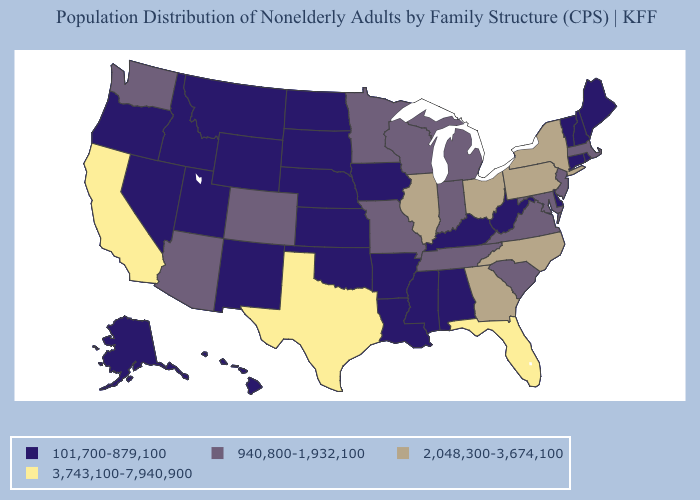What is the value of Minnesota?
Short answer required. 940,800-1,932,100. Does California have the highest value in the West?
Write a very short answer. Yes. Name the states that have a value in the range 2,048,300-3,674,100?
Be succinct. Georgia, Illinois, New York, North Carolina, Ohio, Pennsylvania. Does the map have missing data?
Short answer required. No. What is the value of Kentucky?
Quick response, please. 101,700-879,100. What is the value of Maryland?
Concise answer only. 940,800-1,932,100. Among the states that border North Carolina , does Georgia have the lowest value?
Short answer required. No. Does the map have missing data?
Concise answer only. No. What is the value of Delaware?
Quick response, please. 101,700-879,100. Name the states that have a value in the range 2,048,300-3,674,100?
Concise answer only. Georgia, Illinois, New York, North Carolina, Ohio, Pennsylvania. What is the highest value in the MidWest ?
Write a very short answer. 2,048,300-3,674,100. What is the lowest value in the South?
Quick response, please. 101,700-879,100. What is the lowest value in the West?
Short answer required. 101,700-879,100. What is the value of Vermont?
Short answer required. 101,700-879,100. Name the states that have a value in the range 940,800-1,932,100?
Be succinct. Arizona, Colorado, Indiana, Maryland, Massachusetts, Michigan, Minnesota, Missouri, New Jersey, South Carolina, Tennessee, Virginia, Washington, Wisconsin. 